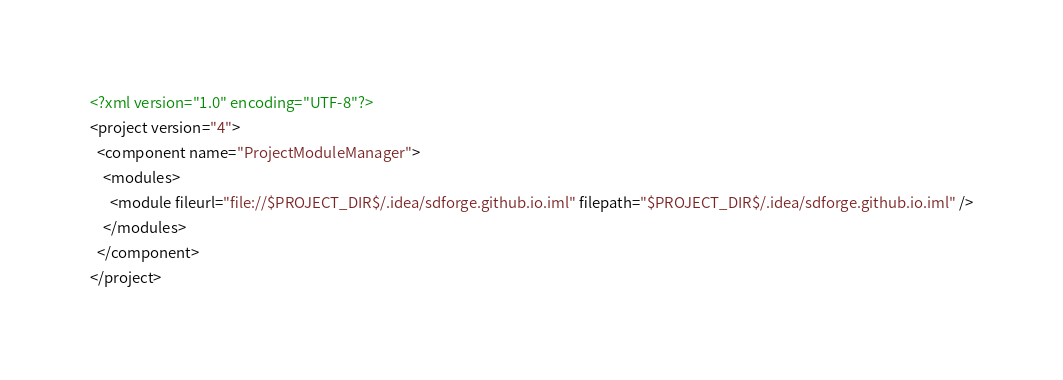<code> <loc_0><loc_0><loc_500><loc_500><_XML_><?xml version="1.0" encoding="UTF-8"?>
<project version="4">
  <component name="ProjectModuleManager">
    <modules>
      <module fileurl="file://$PROJECT_DIR$/.idea/sdforge.github.io.iml" filepath="$PROJECT_DIR$/.idea/sdforge.github.io.iml" />
    </modules>
  </component>
</project></code> 